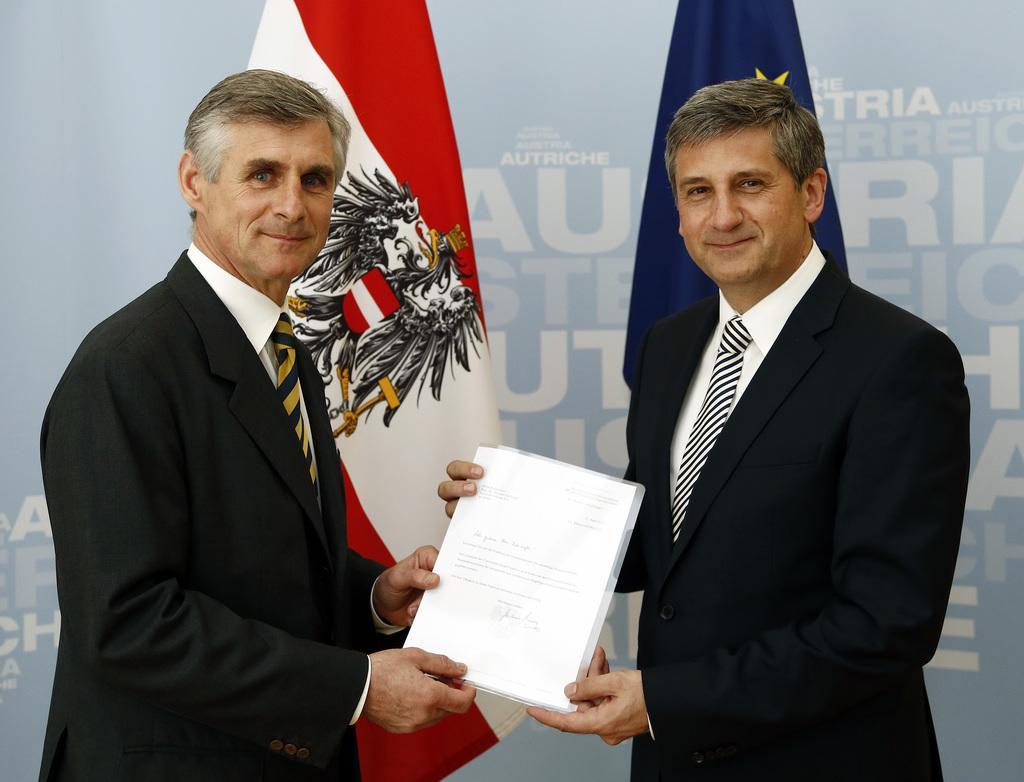In one or two sentences, can you explain what this image depicts? In this image we can see two persons,, they are holding papers, behind them there are flags, and a board with text on it. 